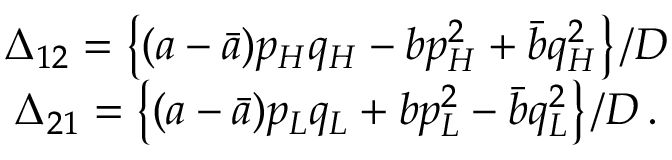<formula> <loc_0><loc_0><loc_500><loc_500>\begin{array} { c } { { \Delta _ { 1 2 } = \left \{ ( a - \bar { a } ) p _ { H } q _ { H } - b p _ { H } ^ { 2 } + \bar { b } q _ { H } ^ { 2 } \right \} / D } } \\ { { \Delta _ { 2 1 } = \left \{ ( a - \bar { a } ) p _ { L } q _ { L } + b p _ { L } ^ { 2 } - \bar { b } q _ { L } ^ { 2 } \right \} / D \, . } } \end{array}</formula> 